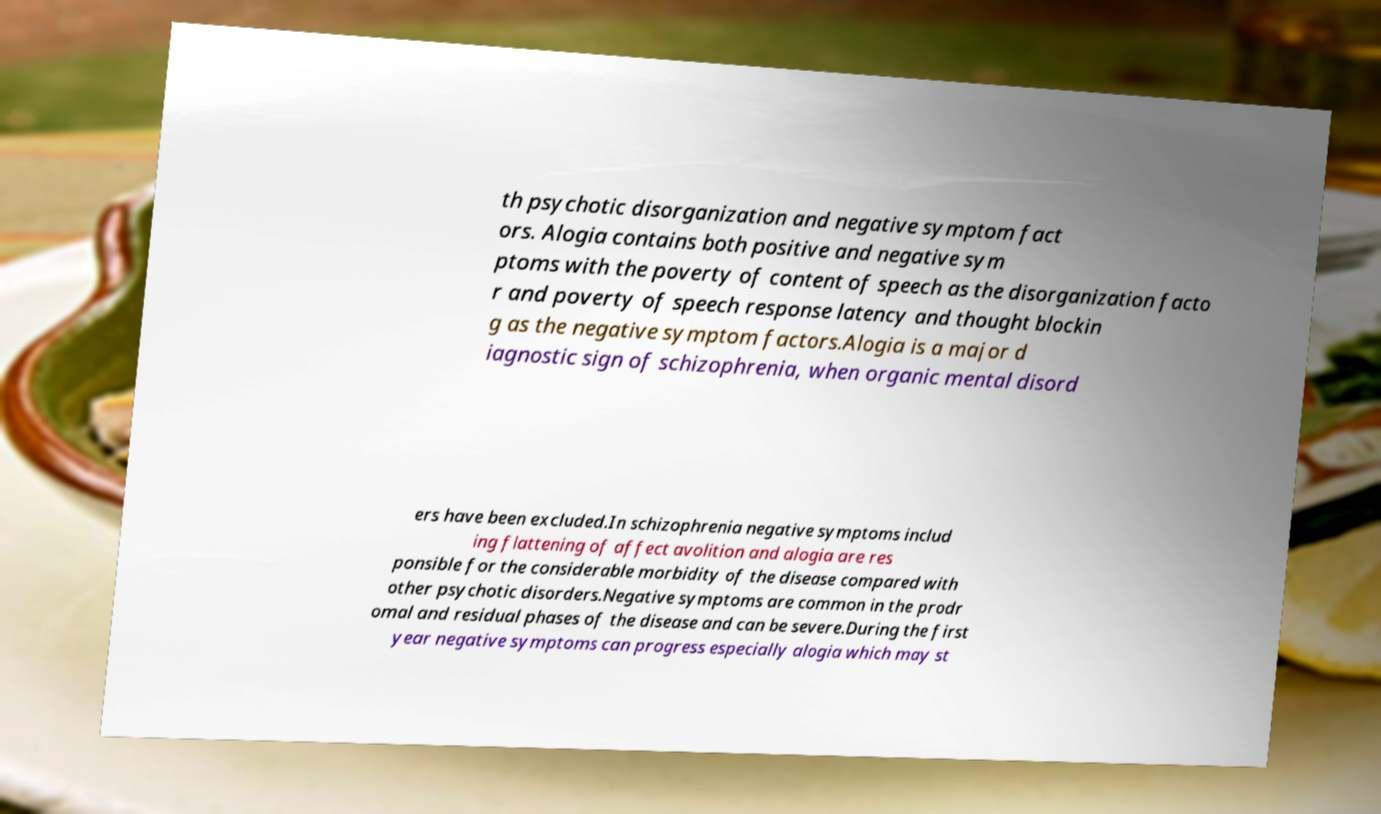For documentation purposes, I need the text within this image transcribed. Could you provide that? th psychotic disorganization and negative symptom fact ors. Alogia contains both positive and negative sym ptoms with the poverty of content of speech as the disorganization facto r and poverty of speech response latency and thought blockin g as the negative symptom factors.Alogia is a major d iagnostic sign of schizophrenia, when organic mental disord ers have been excluded.In schizophrenia negative symptoms includ ing flattening of affect avolition and alogia are res ponsible for the considerable morbidity of the disease compared with other psychotic disorders.Negative symptoms are common in the prodr omal and residual phases of the disease and can be severe.During the first year negative symptoms can progress especially alogia which may st 